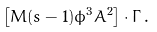Convert formula to latex. <formula><loc_0><loc_0><loc_500><loc_500>\left [ M ( s - 1 ) \phi ^ { 3 } A ^ { 2 } \right ] \cdot \Gamma \, .</formula> 